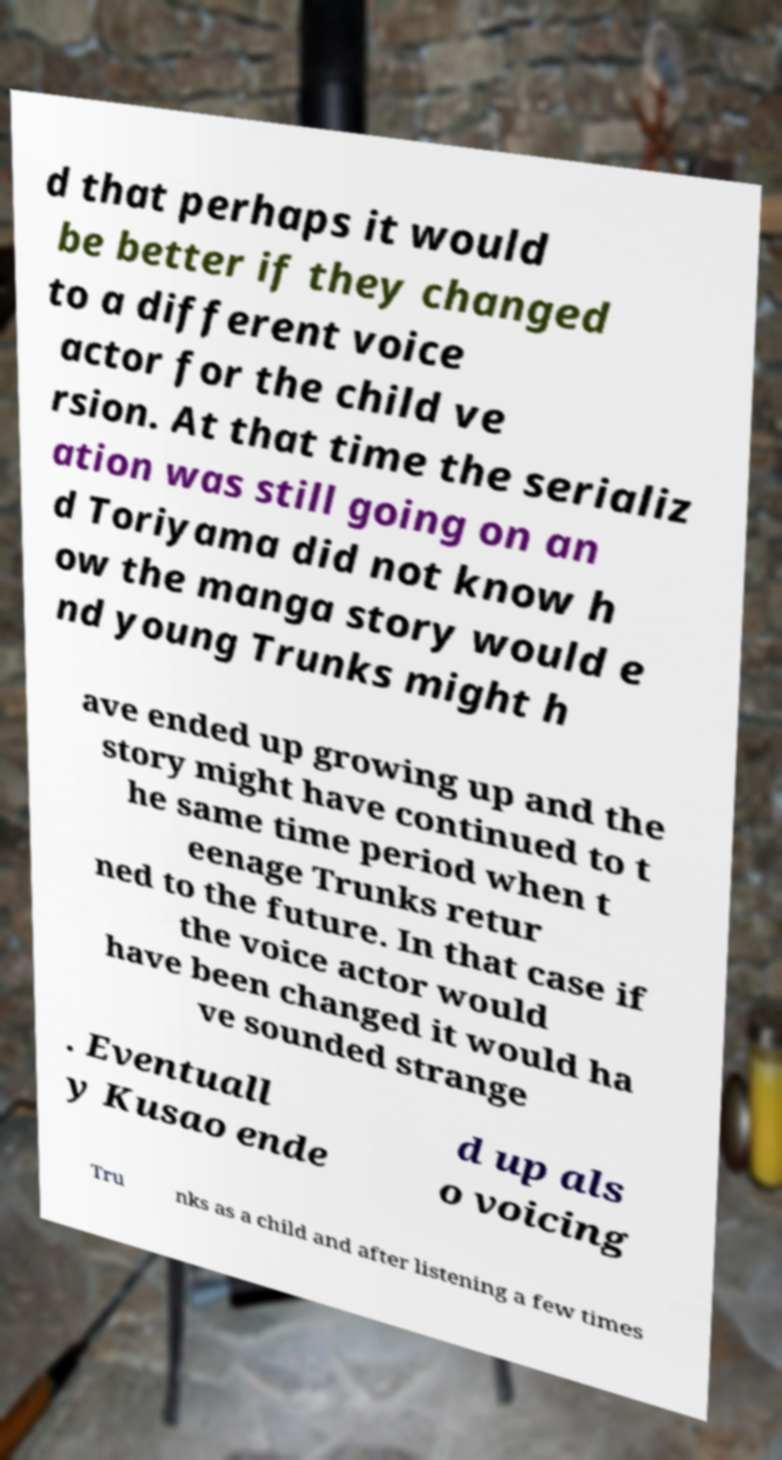What messages or text are displayed in this image? I need them in a readable, typed format. d that perhaps it would be better if they changed to a different voice actor for the child ve rsion. At that time the serializ ation was still going on an d Toriyama did not know h ow the manga story would e nd young Trunks might h ave ended up growing up and the story might have continued to t he same time period when t eenage Trunks retur ned to the future. In that case if the voice actor would have been changed it would ha ve sounded strange . Eventuall y Kusao ende d up als o voicing Tru nks as a child and after listening a few times 